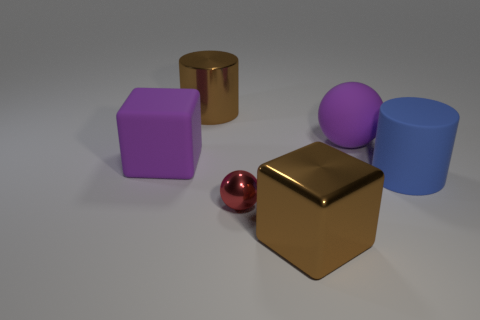Add 3 blue cylinders. How many objects exist? 9 Subtract all red balls. How many balls are left? 1 Subtract all balls. How many objects are left? 4 Subtract 2 cylinders. How many cylinders are left? 0 Add 1 shiny spheres. How many shiny spheres are left? 2 Add 1 large brown metal cylinders. How many large brown metal cylinders exist? 2 Subtract 1 purple blocks. How many objects are left? 5 Subtract all cyan cubes. Subtract all green cylinders. How many cubes are left? 2 Subtract all green balls. How many blue cylinders are left? 1 Subtract all brown rubber cubes. Subtract all small metallic balls. How many objects are left? 5 